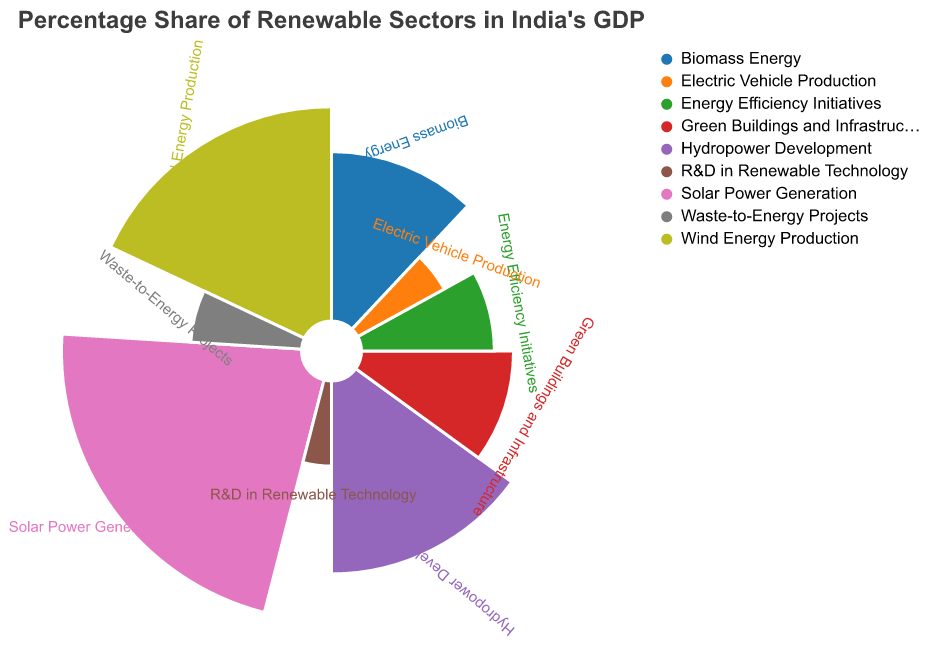What is the sector with the highest percentage share in India's GDP according to the figure? The sector with the largest portion of the Polar Chart represents the highest percentage share. According to the figure, Solar Power Generation has the largest section with 22%.
Answer: Solar Power Generation What is the combined percentage share of Biomass Energy and Energy Efficiency Initiatives? Biomass Energy has a share of 12% and Energy Efficiency Initiatives have 8%. Summing these gives 12% + 8% = 20%.
Answer: 20% How do the shares of Wind Energy Production and Hydropower Development compare? Wind Energy Production has a percentage share of 18%, while Hydropower Development has a 15% share. Wind Energy Production is therefore higher than Hydropower Development by 3%.
Answer: Wind Energy Production has 3% more Which sector has the smallest percentage share and what is its value? The smallest segment in the Polar Chart represents the sector with the lowest share. According to the figure, R&D in Renewable Technology has the smallest share, which is 4%.
Answer: R&D in Renewable Technology What is the total percentage share of sectors related to energy production (Solar, Wind, Hydropower, Biomass)? Summing the percentage shares of Solar Power Generation (22%), Wind Energy Production (18%), Hydropower Development (15%), and Biomass Energy (12%) gives 22% + 18% + 15% + 12% = 67%.
Answer: 67% Which sectors together contribute to less than 20% of India's GDP? Waste-to-Energy Projects (6%), Electric Vehicle Production (5%), and R&D in Renewable Technology (4%) are sectors with shares adding up to 6% + 5% + 4% = 15%, which is less than 20%.
Answer: Waste-to-Energy Projects, Electric Vehicle Production, R&D in Renewable Technology Is the share of Green Buildings and Infrastructure greater than that of Energy Efficiency Initiatives? Green Buildings and Infrastructure has a share of 10%, while Energy Efficiency Initiatives have a share of 8%. Since 10% is greater than 8%, yes, the share is greater.
Answer: Yes What percentage more does Biomass Energy contribute compared to R&D in Renewable Technology? Biomass Energy has a share of 12%, while R&D in Renewable Technology has 4%. The difference is 12% - 4% = 8%.
Answer: 8% How does the share of Waste-to-Energy Projects compare to Electric Vehicle Production? Waste-to-Energy Projects have a percentage share of 6%, while Electric Vehicle Production has 5%. Waste-to-Energy Projects contribute 1% more than Electric Vehicle Production.
Answer: 1% more What is the average percentage share of sectors with more than 10% contribution? The sectors with more than 10% contributions are Solar Power Generation (22%), Wind Energy Production (18%), and Hydropower Development (15%). The average is (22% + 18% + 15%) / 3 = 55% / 3 ≈ 18.33%.
Answer: ≈ 18.33% 